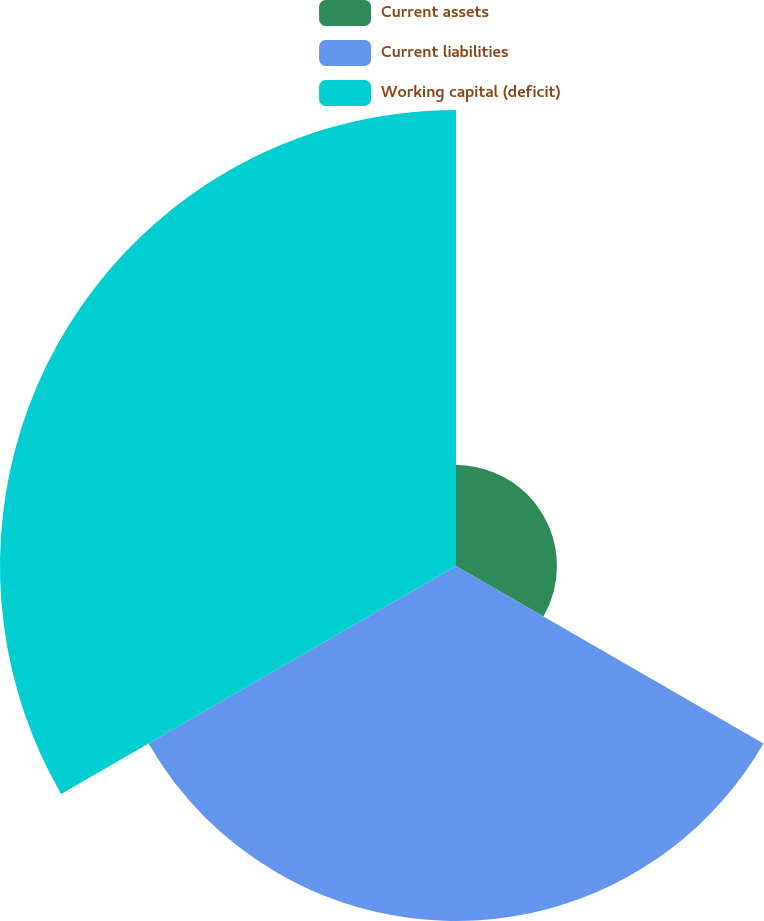Convert chart to OTSL. <chart><loc_0><loc_0><loc_500><loc_500><pie_chart><fcel>Current assets<fcel>Current liabilities<fcel>Working capital (deficit)<nl><fcel>11.07%<fcel>38.93%<fcel>50.0%<nl></chart> 